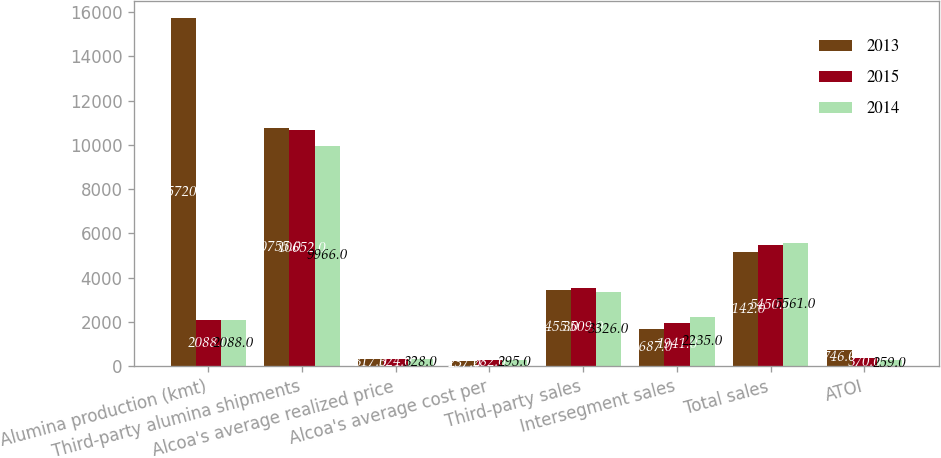Convert chart to OTSL. <chart><loc_0><loc_0><loc_500><loc_500><stacked_bar_chart><ecel><fcel>Alumina production (kmt)<fcel>Third-party alumina shipments<fcel>Alcoa's average realized price<fcel>Alcoa's average cost per<fcel>Third-party sales<fcel>Intersegment sales<fcel>Total sales<fcel>ATOI<nl><fcel>2013<fcel>15720<fcel>10755<fcel>317<fcel>237<fcel>3455<fcel>1687<fcel>5142<fcel>746<nl><fcel>2015<fcel>2088<fcel>10652<fcel>324<fcel>282<fcel>3509<fcel>1941<fcel>5450<fcel>370<nl><fcel>2014<fcel>2088<fcel>9966<fcel>328<fcel>295<fcel>3326<fcel>2235<fcel>5561<fcel>259<nl></chart> 